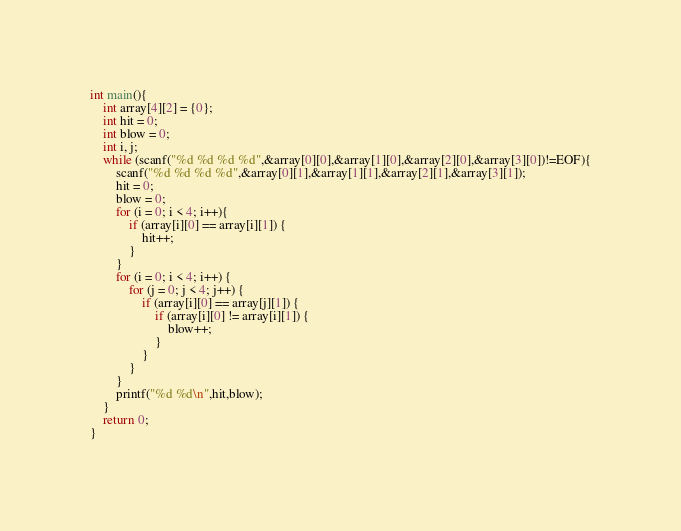<code> <loc_0><loc_0><loc_500><loc_500><_C_>int main(){
    int array[4][2] = {0};
    int hit = 0;
    int blow = 0;
    int i, j;
    while (scanf("%d %d %d %d",&array[0][0],&array[1][0],&array[2][0],&array[3][0])!=EOF){
        scanf("%d %d %d %d",&array[0][1],&array[1][1],&array[2][1],&array[3][1]);
        hit = 0;
        blow = 0;
        for (i = 0; i < 4; i++){
            if (array[i][0] == array[i][1]) {
                hit++;
            }
        }
        for (i = 0; i < 4; i++) {
            for (j = 0; j < 4; j++) {
                if (array[i][0] == array[j][1]) {
                    if (array[i][0] != array[i][1]) {
                        blow++;
                    }
                }
            }
        }
        printf("%d %d\n",hit,blow);
    }
    return 0;
}</code> 